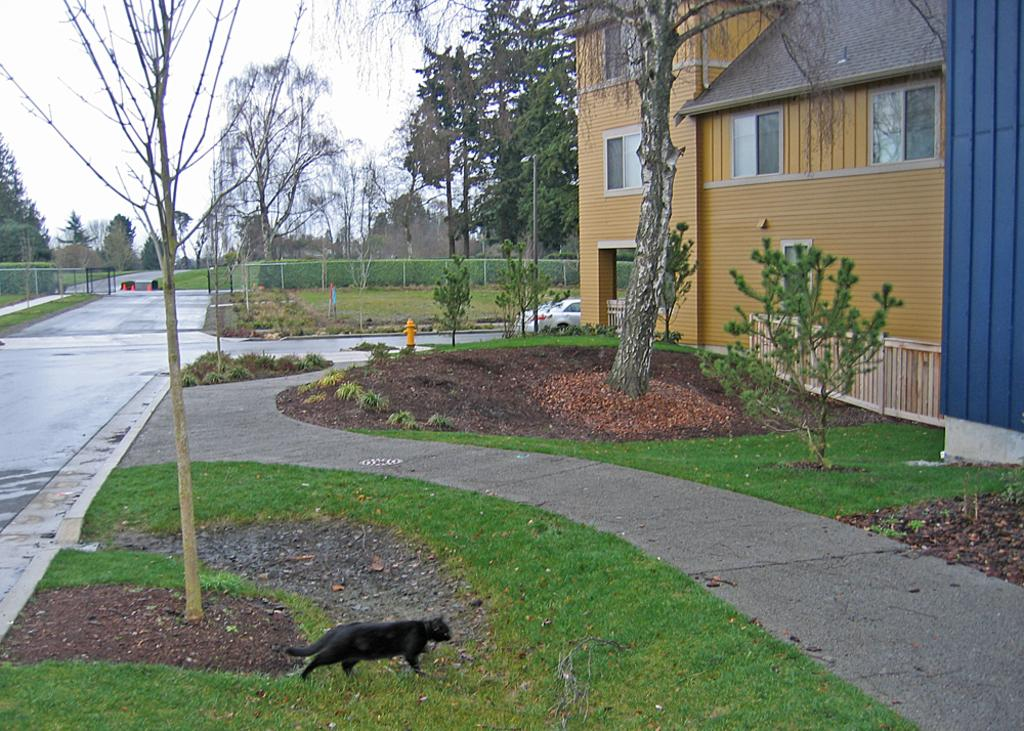What type of natural elements can be seen in the image? There are trees and plants in the image. What type of man-made structures are present in the image? There are poles, a building, and a fence in the image. What type of transportation is visible in the image? There are vehicles on the road in the image. What type of safety equipment is present in the image? There is a fire hydrant in the image. Are there any living creatures visible in the image? Yes, there is an animal on the ground in the image. Can you tell me where the river is located in the image? There is no river present in the image. What type of argument is taking place between the trees in the image? There is no argument taking place in the image; it is a still image of trees, poles, a building, vehicles, a fire hydrant, a fence, plants, and an animal. What type of monkey can be seen climbing the fence in the image? There is no monkey present in the image. 